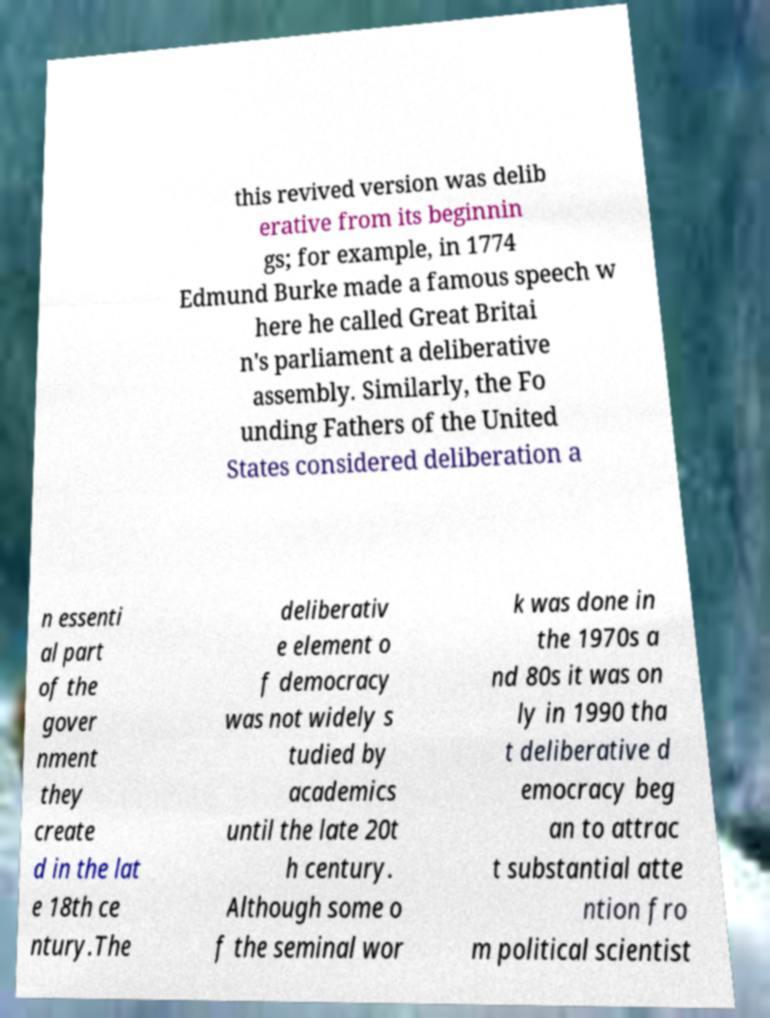Could you assist in decoding the text presented in this image and type it out clearly? this revived version was delib erative from its beginnin gs; for example, in 1774 Edmund Burke made a famous speech w here he called Great Britai n's parliament a deliberative assembly. Similarly, the Fo unding Fathers of the United States considered deliberation a n essenti al part of the gover nment they create d in the lat e 18th ce ntury.The deliberativ e element o f democracy was not widely s tudied by academics until the late 20t h century. Although some o f the seminal wor k was done in the 1970s a nd 80s it was on ly in 1990 tha t deliberative d emocracy beg an to attrac t substantial atte ntion fro m political scientist 